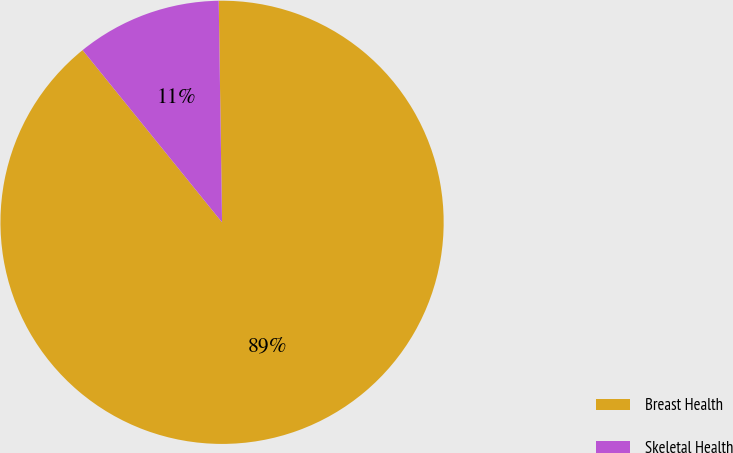<chart> <loc_0><loc_0><loc_500><loc_500><pie_chart><fcel>Breast Health<fcel>Skeletal Health<nl><fcel>89.41%<fcel>10.59%<nl></chart> 